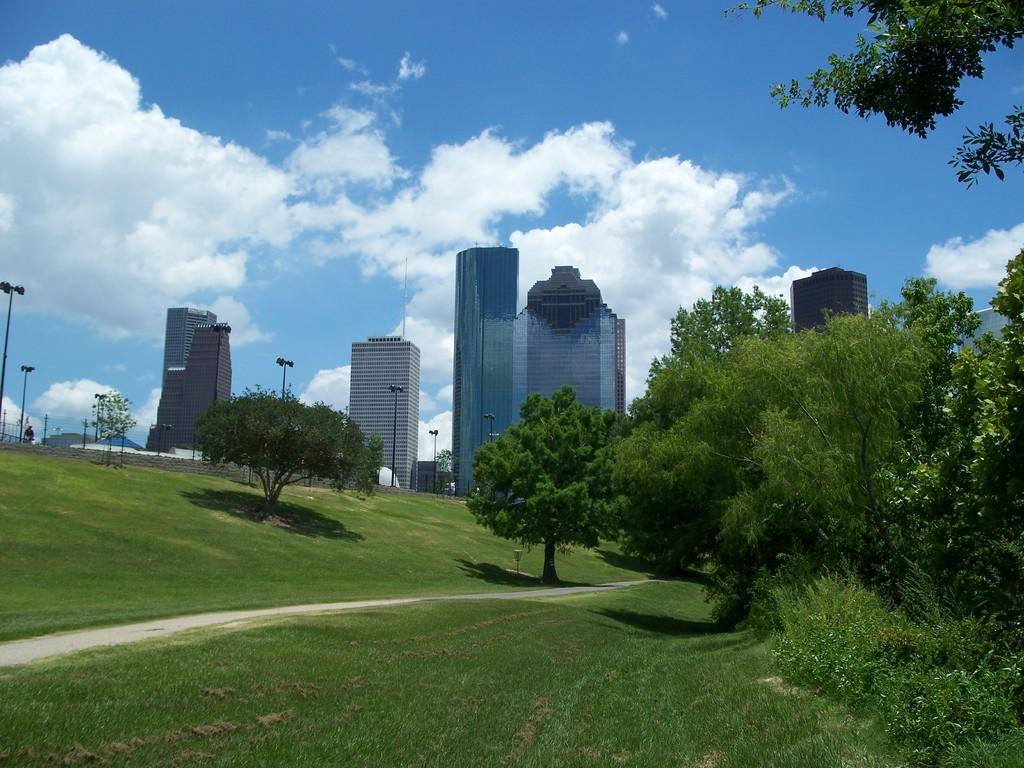What type of vegetation is visible in the front of the image? There is grass and trees in the front of the image. What type of structures can be seen in the background of the image? There are buildings in the background of the image. What type of lighting is present in the background of the image? There are light poles in the background of the image. What is the condition of the sky in the background of the image? The sky is cloudy in the background of the image. What else can be seen in the background of the image? There are objects in the background of the image. How many cars are driving on the grass in the image? There are no cars driving on the grass in the image. What type of pollution is visible in the image? There is no pollution visible in the image. 